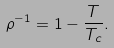Convert formula to latex. <formula><loc_0><loc_0><loc_500><loc_500>\rho ^ { - 1 } = 1 - \frac { T } { T _ { c } } .</formula> 